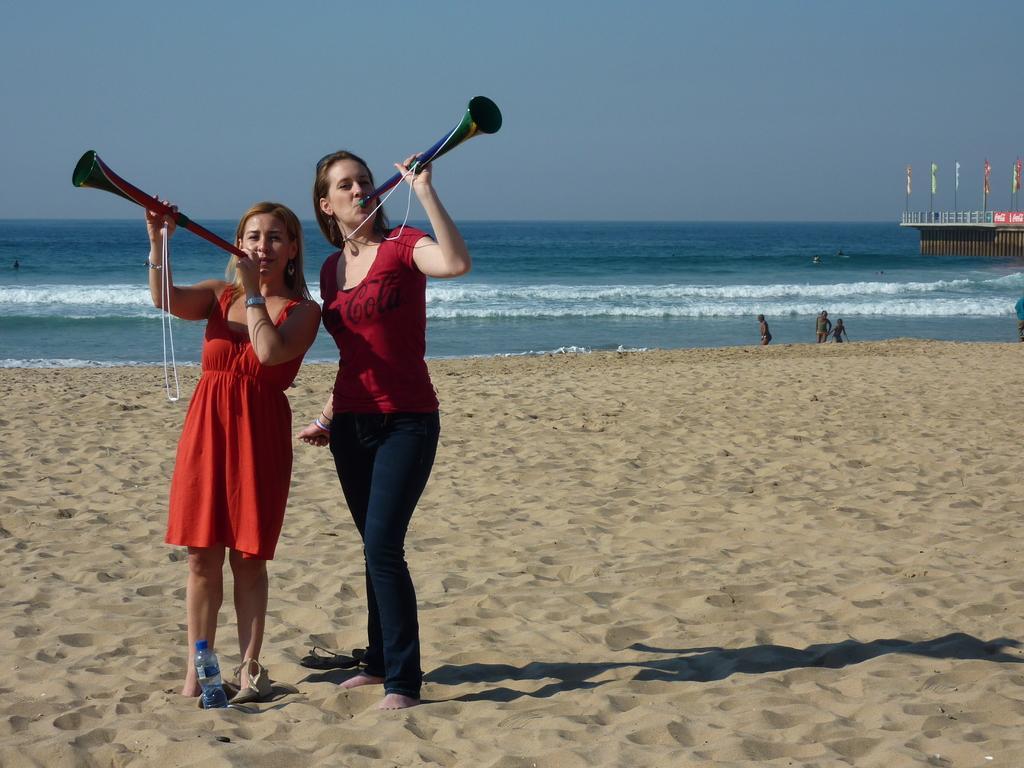Please provide a concise description of this image. In this image we can see two ladies holding musical instruments. They are standing on sand. Also there is a bottle. In the back there is water. And there are few people. On the right side there is a wall with railing and flags. In the background there is sky. 